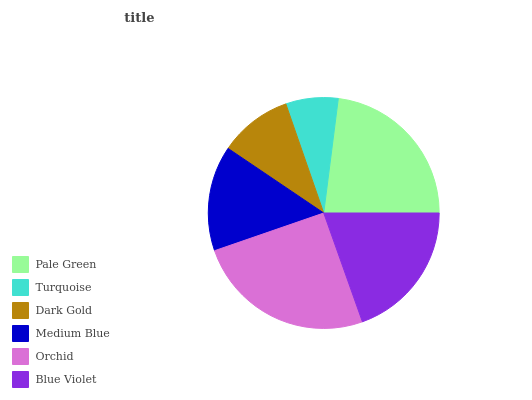Is Turquoise the minimum?
Answer yes or no. Yes. Is Orchid the maximum?
Answer yes or no. Yes. Is Dark Gold the minimum?
Answer yes or no. No. Is Dark Gold the maximum?
Answer yes or no. No. Is Dark Gold greater than Turquoise?
Answer yes or no. Yes. Is Turquoise less than Dark Gold?
Answer yes or no. Yes. Is Turquoise greater than Dark Gold?
Answer yes or no. No. Is Dark Gold less than Turquoise?
Answer yes or no. No. Is Blue Violet the high median?
Answer yes or no. Yes. Is Medium Blue the low median?
Answer yes or no. Yes. Is Medium Blue the high median?
Answer yes or no. No. Is Blue Violet the low median?
Answer yes or no. No. 